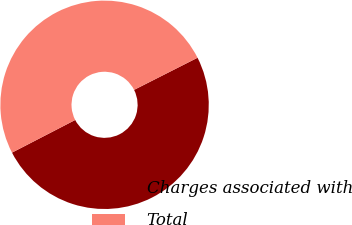Convert chart. <chart><loc_0><loc_0><loc_500><loc_500><pie_chart><fcel>Charges associated with<fcel>Total<nl><fcel>49.87%<fcel>50.13%<nl></chart> 